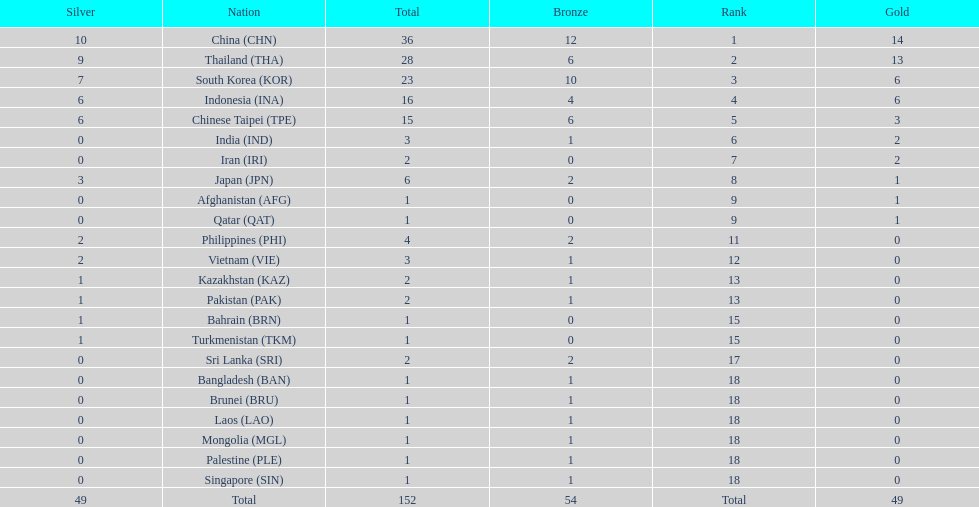How many nations received a medal in each gold, silver, and bronze? 6. 